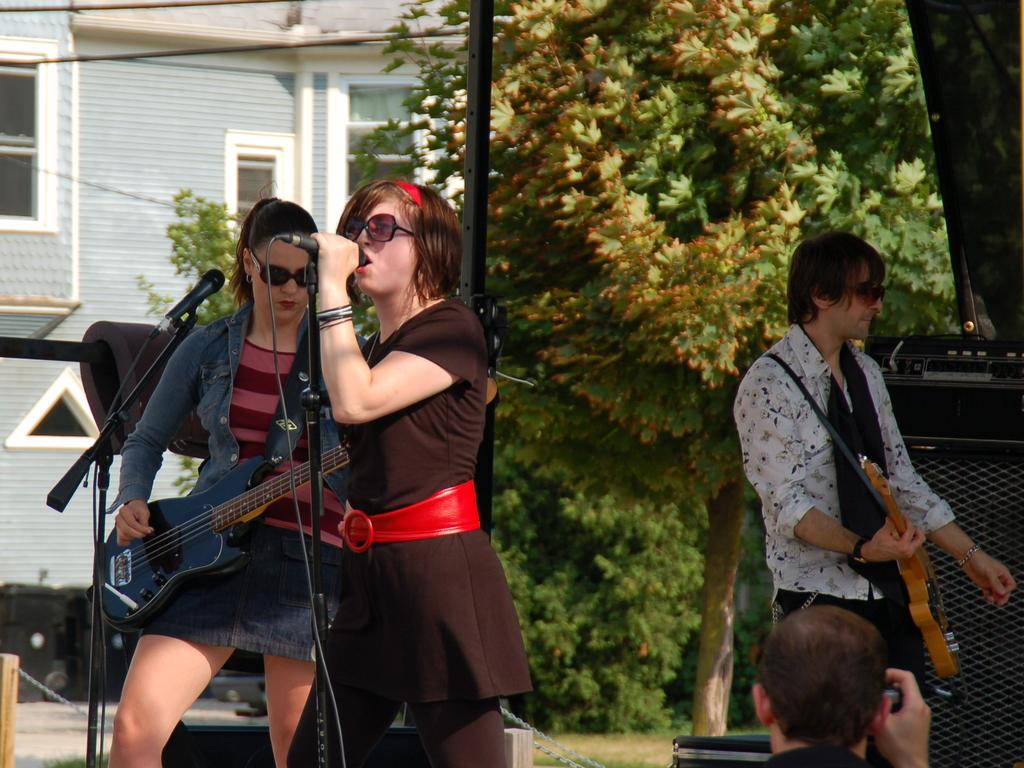How many people are in the image? There are three people in the image. What are the people doing in the image? The people are playing musical instruments and singing a song. Where are the people located in the image? They are in front of a microphone. What can be seen in the background of the image? There is a house and a tree in the background of the image. Can you see a goldfish swimming near the tree in the background of the image? There is no goldfish present in the image; it features people playing musical instruments and singing in front of a microphone, with a house and a tree in the background. 